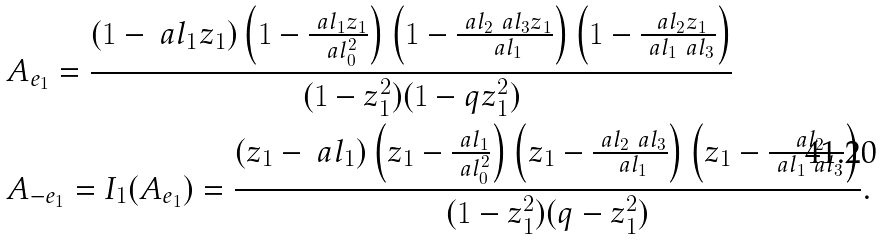<formula> <loc_0><loc_0><loc_500><loc_500>& A _ { e _ { 1 } } = \frac { ( 1 - \ a l _ { 1 } z _ { 1 } ) \left ( 1 - \frac { \ a l _ { 1 } z _ { 1 } } { \ a l _ { 0 } ^ { 2 } } \right ) \left ( 1 - \frac { \ a l _ { 2 } \ a l _ { 3 } z _ { 1 } } { \ a l _ { 1 } } \right ) \left ( 1 - \frac { \ a l _ { 2 } z _ { 1 } } { \ a l _ { 1 } \ a l _ { 3 } } \right ) } { ( 1 - z _ { 1 } ^ { 2 } ) ( 1 - q z _ { 1 } ^ { 2 } ) } \\ & A _ { - e _ { 1 } } = I _ { 1 } ( A _ { e _ { 1 } } ) = \frac { ( z _ { 1 } - \ a l _ { 1 } ) \left ( z _ { 1 } - \frac { \ a l _ { 1 } } { \ a l _ { 0 } ^ { 2 } } \right ) \left ( z _ { 1 } - \frac { \ a l _ { 2 } \ a l _ { 3 } } { \ a l _ { 1 } } \right ) \left ( z _ { 1 } - \frac { \ a l _ { 2 } } { \ a l _ { 1 } \ a l _ { 3 } } \right ) } { ( 1 - z _ { 1 } ^ { 2 } ) ( q - z _ { 1 } ^ { 2 } ) } .</formula> 